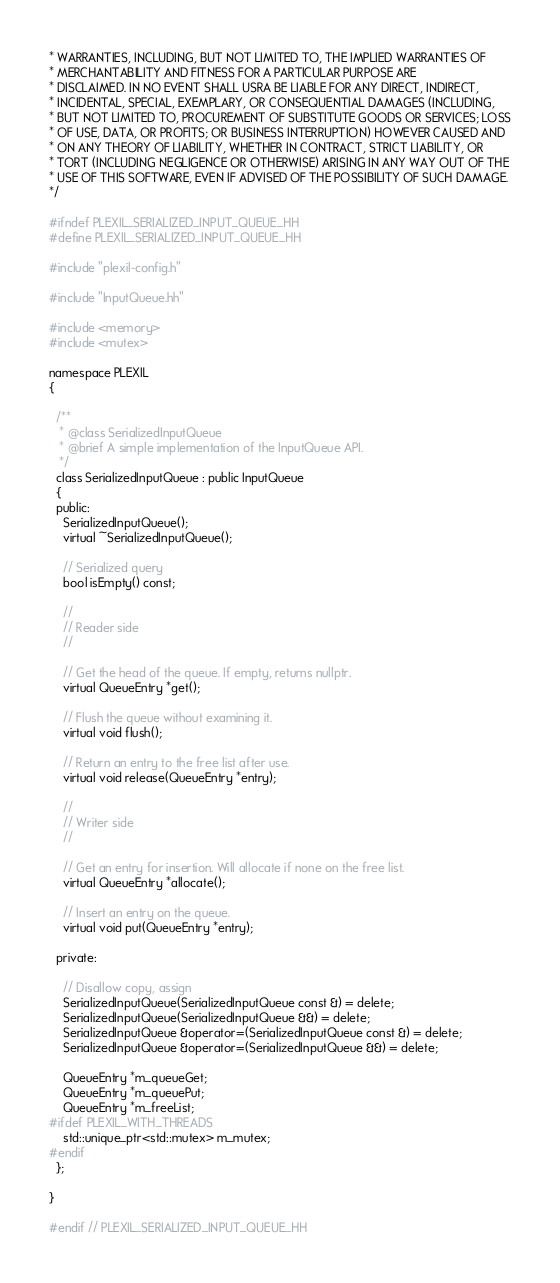<code> <loc_0><loc_0><loc_500><loc_500><_C++_>* WARRANTIES, INCLUDING, BUT NOT LIMITED TO, THE IMPLIED WARRANTIES OF
* MERCHANTABILITY AND FITNESS FOR A PARTICULAR PURPOSE ARE
* DISCLAIMED. IN NO EVENT SHALL USRA BE LIABLE FOR ANY DIRECT, INDIRECT,
* INCIDENTAL, SPECIAL, EXEMPLARY, OR CONSEQUENTIAL DAMAGES (INCLUDING,
* BUT NOT LIMITED TO, PROCUREMENT OF SUBSTITUTE GOODS OR SERVICES; LOSS
* OF USE, DATA, OR PROFITS; OR BUSINESS INTERRUPTION) HOWEVER CAUSED AND
* ON ANY THEORY OF LIABILITY, WHETHER IN CONTRACT, STRICT LIABILITY, OR
* TORT (INCLUDING NEGLIGENCE OR OTHERWISE) ARISING IN ANY WAY OUT OF THE
* USE OF THIS SOFTWARE, EVEN IF ADVISED OF THE POSSIBILITY OF SUCH DAMAGE.
*/

#ifndef PLEXIL_SERIALIZED_INPUT_QUEUE_HH
#define PLEXIL_SERIALIZED_INPUT_QUEUE_HH

#include "plexil-config.h"

#include "InputQueue.hh"

#include <memory>
#include <mutex>

namespace PLEXIL
{

  /**
   * @class SerializedInputQueue
   * @brief A simple implementation of the InputQueue API.
   */
  class SerializedInputQueue : public InputQueue
  {
  public:
    SerializedInputQueue();
    virtual ~SerializedInputQueue();

    // Serialized query
    bool isEmpty() const;

    //
    // Reader side
    //

    // Get the head of the queue. If empty, returns nullptr.
    virtual QueueEntry *get();

    // Flush the queue without examining it.
    virtual void flush();

    // Return an entry to the free list after use.
    virtual void release(QueueEntry *entry);

    //
    // Writer side
    //

    // Get an entry for insertion. Will allocate if none on the free list.
    virtual QueueEntry *allocate();

    // Insert an entry on the queue.
    virtual void put(QueueEntry *entry);

  private:

    // Disallow copy, assign
    SerializedInputQueue(SerializedInputQueue const &) = delete;
    SerializedInputQueue(SerializedInputQueue &&) = delete;
    SerializedInputQueue &operator=(SerializedInputQueue const &) = delete;
    SerializedInputQueue &operator=(SerializedInputQueue &&) = delete;

    QueueEntry *m_queueGet;
    QueueEntry *m_queuePut;
    QueueEntry *m_freeList;
#ifdef PLEXIL_WITH_THREADS
    std::unique_ptr<std::mutex> m_mutex;
#endif
  };

}

#endif // PLEXIL_SERIALIZED_INPUT_QUEUE_HH
</code> 